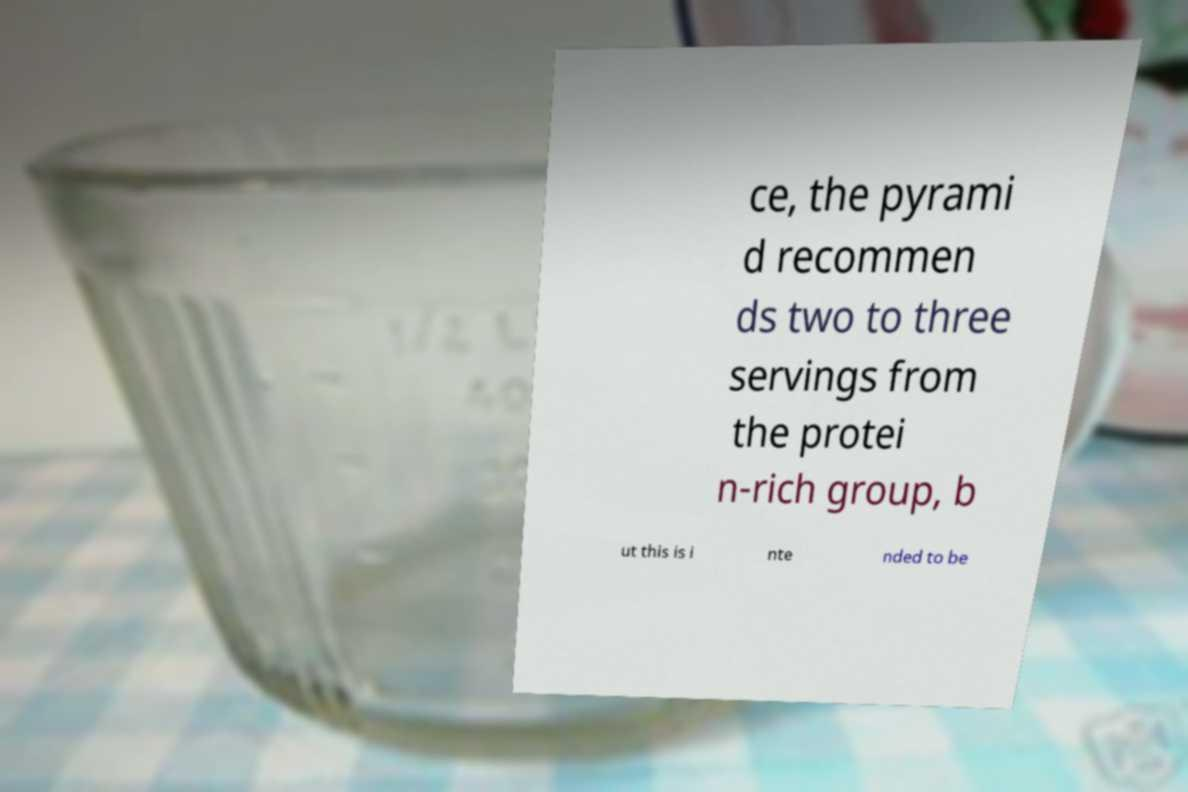Can you accurately transcribe the text from the provided image for me? ce, the pyrami d recommen ds two to three servings from the protei n-rich group, b ut this is i nte nded to be 